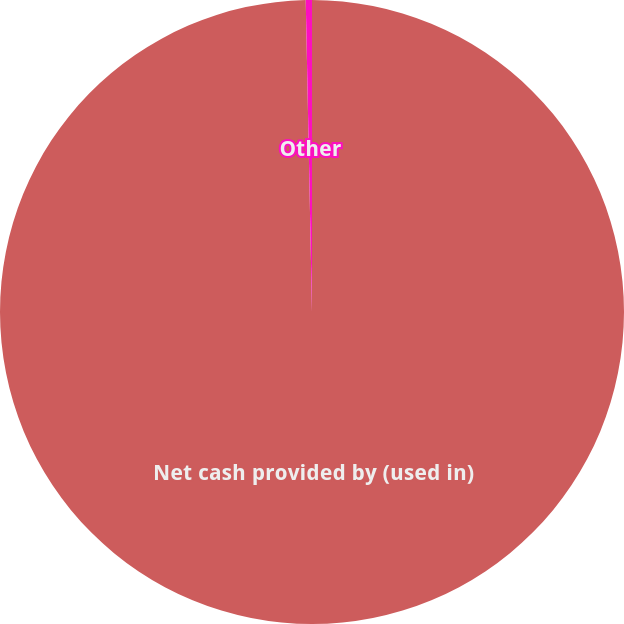Convert chart to OTSL. <chart><loc_0><loc_0><loc_500><loc_500><pie_chart><fcel>Net cash provided by (used in)<fcel>Other<nl><fcel>99.68%<fcel>0.32%<nl></chart> 